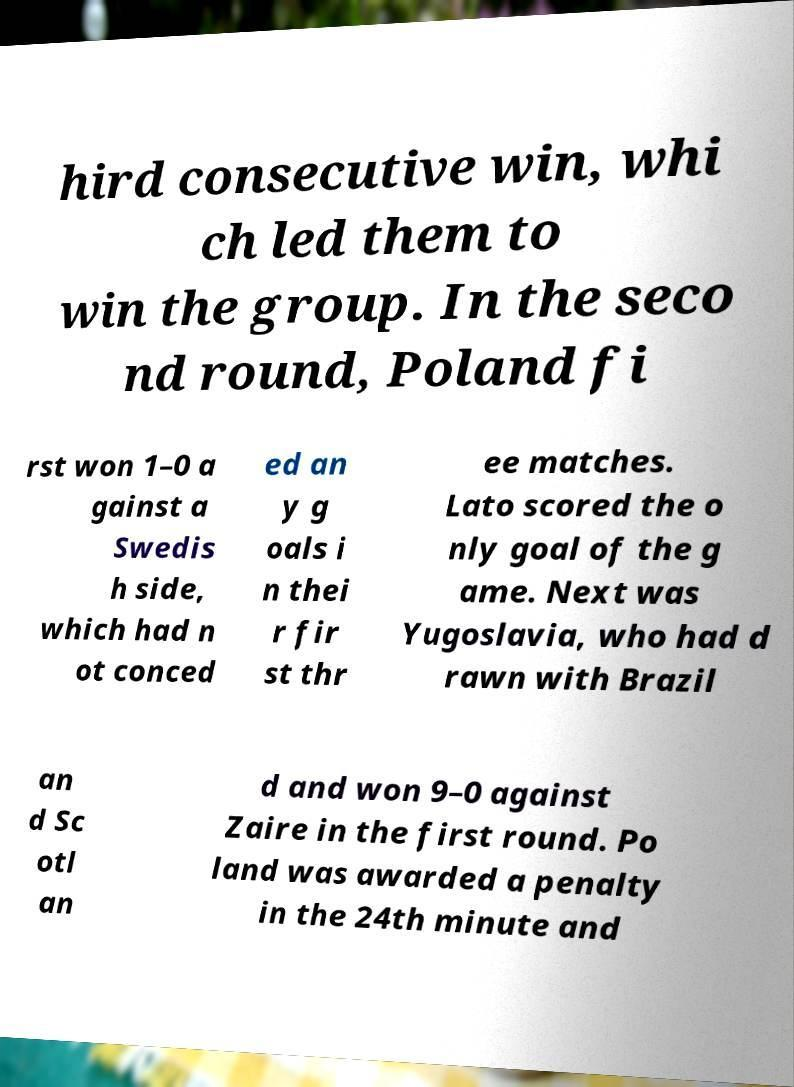Can you accurately transcribe the text from the provided image for me? hird consecutive win, whi ch led them to win the group. In the seco nd round, Poland fi rst won 1–0 a gainst a Swedis h side, which had n ot conced ed an y g oals i n thei r fir st thr ee matches. Lato scored the o nly goal of the g ame. Next was Yugoslavia, who had d rawn with Brazil an d Sc otl an d and won 9–0 against Zaire in the first round. Po land was awarded a penalty in the 24th minute and 